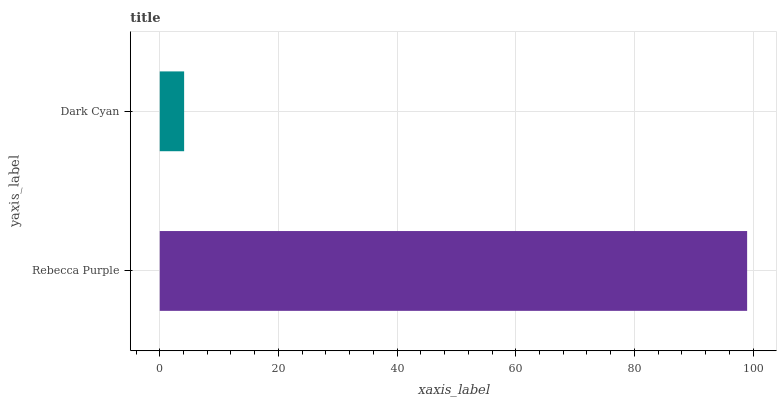Is Dark Cyan the minimum?
Answer yes or no. Yes. Is Rebecca Purple the maximum?
Answer yes or no. Yes. Is Dark Cyan the maximum?
Answer yes or no. No. Is Rebecca Purple greater than Dark Cyan?
Answer yes or no. Yes. Is Dark Cyan less than Rebecca Purple?
Answer yes or no. Yes. Is Dark Cyan greater than Rebecca Purple?
Answer yes or no. No. Is Rebecca Purple less than Dark Cyan?
Answer yes or no. No. Is Rebecca Purple the high median?
Answer yes or no. Yes. Is Dark Cyan the low median?
Answer yes or no. Yes. Is Dark Cyan the high median?
Answer yes or no. No. Is Rebecca Purple the low median?
Answer yes or no. No. 